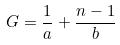Convert formula to latex. <formula><loc_0><loc_0><loc_500><loc_500>G = \frac { 1 } { a } + \frac { n - 1 } { b }</formula> 